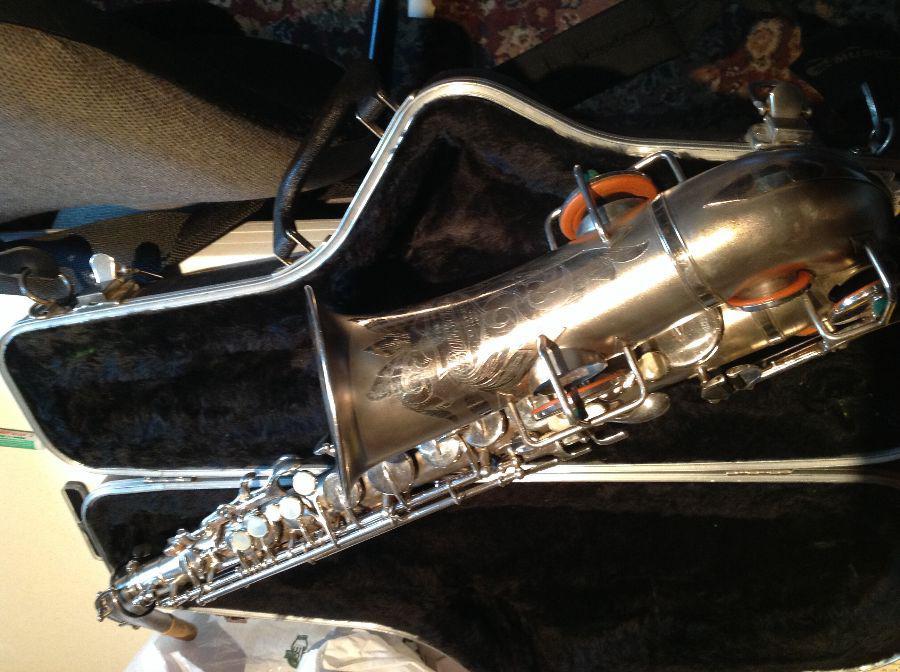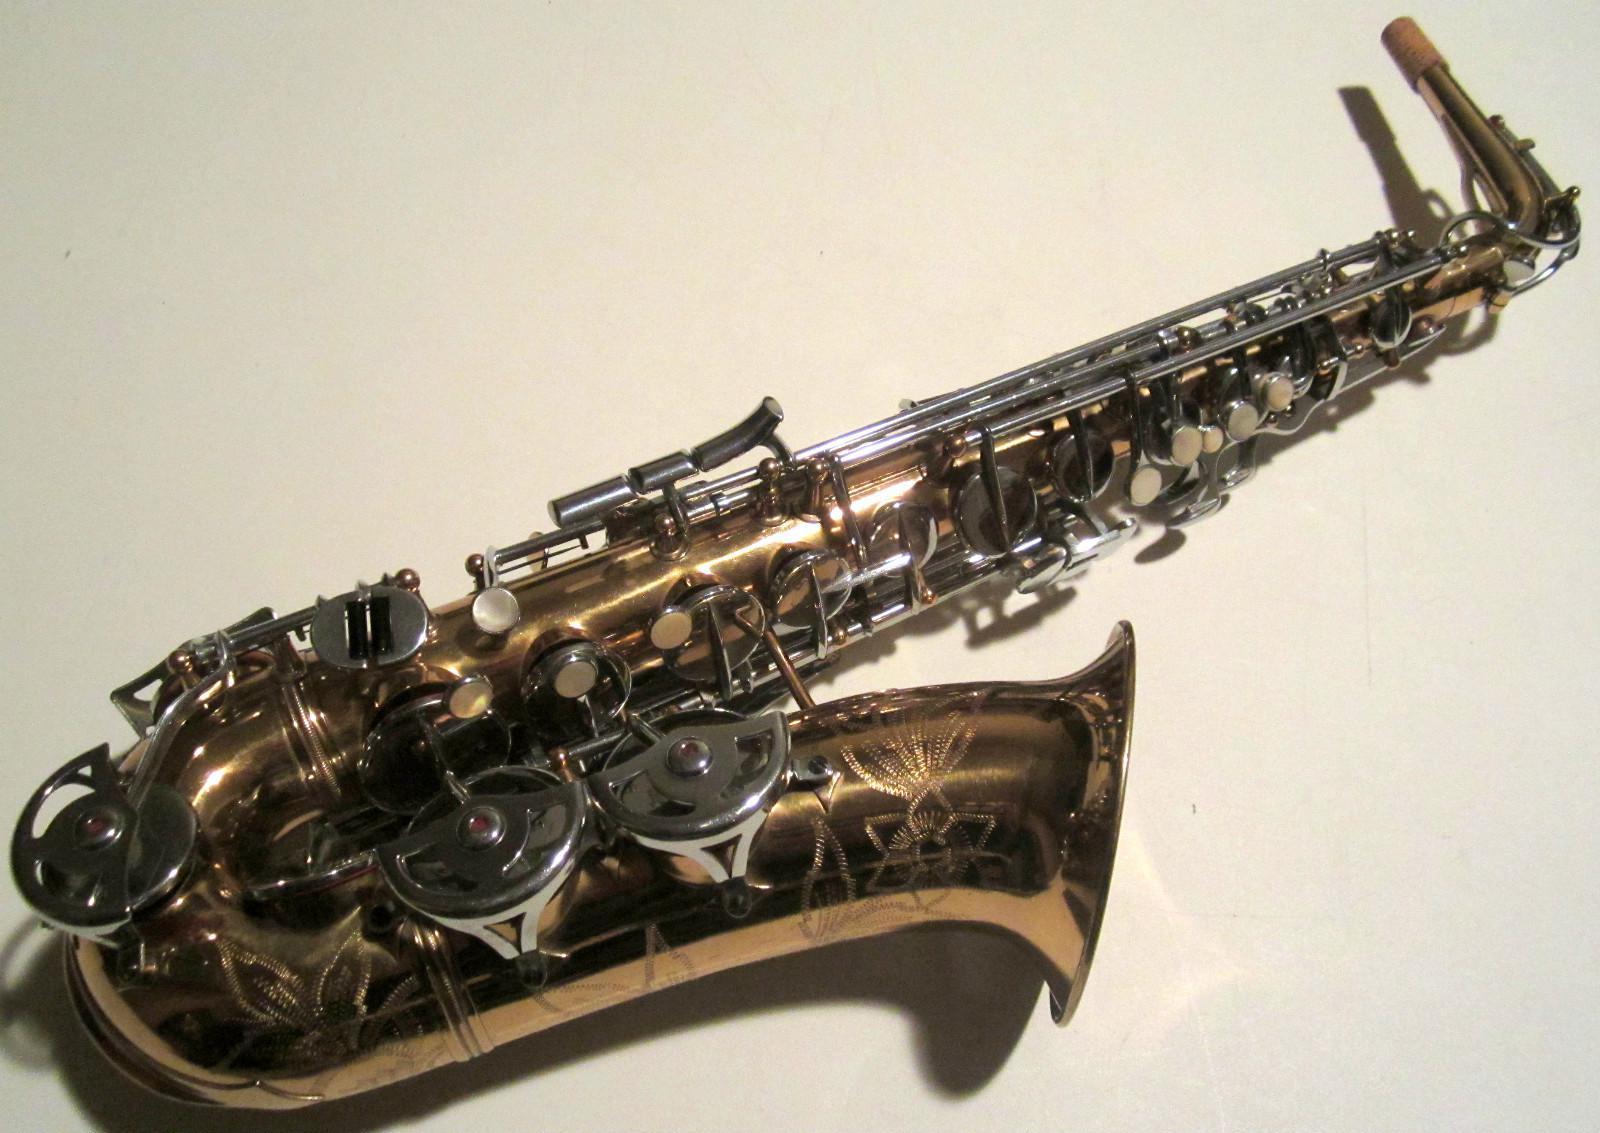The first image is the image on the left, the second image is the image on the right. Examine the images to the left and right. Is the description "The left image shows a saxophone displayed in front of an open black case, and the right image features a saxophone displayed without a case." accurate? Answer yes or no. Yes. The first image is the image on the left, the second image is the image on the right. Given the left and right images, does the statement "The sax in the image on the left has etching on it." hold true? Answer yes or no. Yes. 